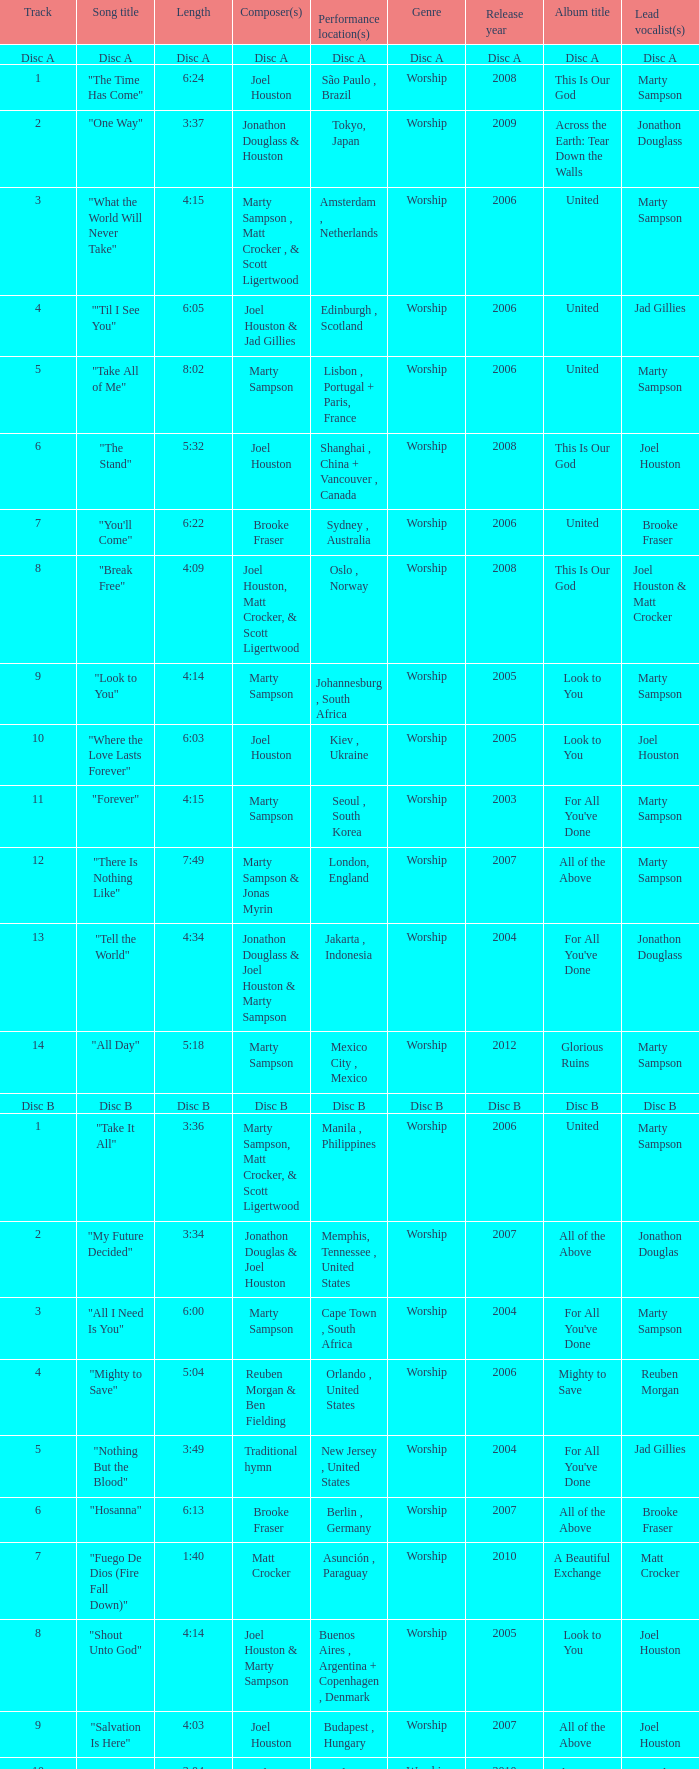What is the lengtho f track 16? 5:55. 